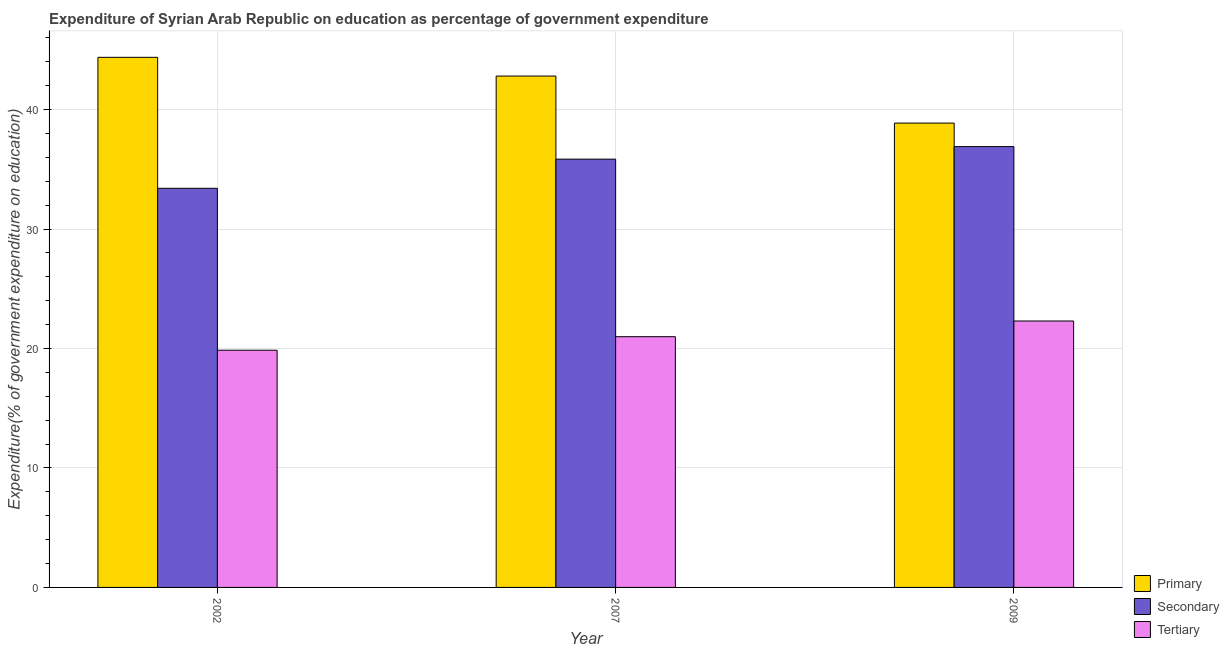How many different coloured bars are there?
Make the answer very short. 3. How many bars are there on the 3rd tick from the left?
Your answer should be very brief. 3. In how many cases, is the number of bars for a given year not equal to the number of legend labels?
Your response must be concise. 0. What is the expenditure on secondary education in 2009?
Provide a short and direct response. 36.9. Across all years, what is the maximum expenditure on primary education?
Provide a short and direct response. 44.38. Across all years, what is the minimum expenditure on tertiary education?
Provide a short and direct response. 19.86. In which year was the expenditure on secondary education maximum?
Offer a terse response. 2009. What is the total expenditure on primary education in the graph?
Your answer should be very brief. 126.06. What is the difference between the expenditure on secondary education in 2007 and that in 2009?
Keep it short and to the point. -1.05. What is the difference between the expenditure on secondary education in 2007 and the expenditure on primary education in 2002?
Offer a terse response. 2.44. What is the average expenditure on secondary education per year?
Make the answer very short. 35.39. In the year 2007, what is the difference between the expenditure on primary education and expenditure on secondary education?
Your answer should be very brief. 0. What is the ratio of the expenditure on tertiary education in 2002 to that in 2009?
Give a very brief answer. 0.89. What is the difference between the highest and the second highest expenditure on tertiary education?
Provide a short and direct response. 1.31. What is the difference between the highest and the lowest expenditure on secondary education?
Provide a short and direct response. 3.49. Is the sum of the expenditure on tertiary education in 2007 and 2009 greater than the maximum expenditure on primary education across all years?
Your response must be concise. Yes. What does the 3rd bar from the left in 2002 represents?
Your answer should be compact. Tertiary. What does the 2nd bar from the right in 2007 represents?
Keep it short and to the point. Secondary. Is it the case that in every year, the sum of the expenditure on primary education and expenditure on secondary education is greater than the expenditure on tertiary education?
Provide a short and direct response. Yes. Are all the bars in the graph horizontal?
Offer a very short reply. No. Are the values on the major ticks of Y-axis written in scientific E-notation?
Keep it short and to the point. No. What is the title of the graph?
Offer a very short reply. Expenditure of Syrian Arab Republic on education as percentage of government expenditure. What is the label or title of the X-axis?
Your response must be concise. Year. What is the label or title of the Y-axis?
Offer a very short reply. Expenditure(% of government expenditure on education). What is the Expenditure(% of government expenditure on education) of Primary in 2002?
Keep it short and to the point. 44.38. What is the Expenditure(% of government expenditure on education) of Secondary in 2002?
Give a very brief answer. 33.41. What is the Expenditure(% of government expenditure on education) in Tertiary in 2002?
Offer a very short reply. 19.86. What is the Expenditure(% of government expenditure on education) of Primary in 2007?
Your answer should be very brief. 42.81. What is the Expenditure(% of government expenditure on education) of Secondary in 2007?
Offer a terse response. 35.85. What is the Expenditure(% of government expenditure on education) in Tertiary in 2007?
Your answer should be very brief. 20.99. What is the Expenditure(% of government expenditure on education) in Primary in 2009?
Make the answer very short. 38.87. What is the Expenditure(% of government expenditure on education) in Secondary in 2009?
Offer a terse response. 36.9. What is the Expenditure(% of government expenditure on education) of Tertiary in 2009?
Your answer should be very brief. 22.31. Across all years, what is the maximum Expenditure(% of government expenditure on education) in Primary?
Your answer should be very brief. 44.38. Across all years, what is the maximum Expenditure(% of government expenditure on education) in Secondary?
Provide a succinct answer. 36.9. Across all years, what is the maximum Expenditure(% of government expenditure on education) of Tertiary?
Your answer should be very brief. 22.31. Across all years, what is the minimum Expenditure(% of government expenditure on education) of Primary?
Make the answer very short. 38.87. Across all years, what is the minimum Expenditure(% of government expenditure on education) in Secondary?
Your answer should be very brief. 33.41. Across all years, what is the minimum Expenditure(% of government expenditure on education) of Tertiary?
Keep it short and to the point. 19.86. What is the total Expenditure(% of government expenditure on education) of Primary in the graph?
Give a very brief answer. 126.06. What is the total Expenditure(% of government expenditure on education) of Secondary in the graph?
Offer a terse response. 106.17. What is the total Expenditure(% of government expenditure on education) of Tertiary in the graph?
Offer a terse response. 63.15. What is the difference between the Expenditure(% of government expenditure on education) of Primary in 2002 and that in 2007?
Make the answer very short. 1.57. What is the difference between the Expenditure(% of government expenditure on education) in Secondary in 2002 and that in 2007?
Keep it short and to the point. -2.44. What is the difference between the Expenditure(% of government expenditure on education) of Tertiary in 2002 and that in 2007?
Offer a very short reply. -1.13. What is the difference between the Expenditure(% of government expenditure on education) in Primary in 2002 and that in 2009?
Make the answer very short. 5.51. What is the difference between the Expenditure(% of government expenditure on education) in Secondary in 2002 and that in 2009?
Your response must be concise. -3.49. What is the difference between the Expenditure(% of government expenditure on education) of Tertiary in 2002 and that in 2009?
Provide a succinct answer. -2.45. What is the difference between the Expenditure(% of government expenditure on education) in Primary in 2007 and that in 2009?
Offer a terse response. 3.94. What is the difference between the Expenditure(% of government expenditure on education) in Secondary in 2007 and that in 2009?
Your answer should be very brief. -1.05. What is the difference between the Expenditure(% of government expenditure on education) of Tertiary in 2007 and that in 2009?
Your response must be concise. -1.31. What is the difference between the Expenditure(% of government expenditure on education) of Primary in 2002 and the Expenditure(% of government expenditure on education) of Secondary in 2007?
Your answer should be compact. 8.52. What is the difference between the Expenditure(% of government expenditure on education) of Primary in 2002 and the Expenditure(% of government expenditure on education) of Tertiary in 2007?
Make the answer very short. 23.39. What is the difference between the Expenditure(% of government expenditure on education) of Secondary in 2002 and the Expenditure(% of government expenditure on education) of Tertiary in 2007?
Provide a short and direct response. 12.42. What is the difference between the Expenditure(% of government expenditure on education) of Primary in 2002 and the Expenditure(% of government expenditure on education) of Secondary in 2009?
Provide a short and direct response. 7.47. What is the difference between the Expenditure(% of government expenditure on education) of Primary in 2002 and the Expenditure(% of government expenditure on education) of Tertiary in 2009?
Your response must be concise. 22.07. What is the difference between the Expenditure(% of government expenditure on education) in Secondary in 2002 and the Expenditure(% of government expenditure on education) in Tertiary in 2009?
Provide a short and direct response. 11.11. What is the difference between the Expenditure(% of government expenditure on education) of Primary in 2007 and the Expenditure(% of government expenditure on education) of Secondary in 2009?
Give a very brief answer. 5.91. What is the difference between the Expenditure(% of government expenditure on education) in Primary in 2007 and the Expenditure(% of government expenditure on education) in Tertiary in 2009?
Offer a very short reply. 20.5. What is the difference between the Expenditure(% of government expenditure on education) in Secondary in 2007 and the Expenditure(% of government expenditure on education) in Tertiary in 2009?
Ensure brevity in your answer.  13.55. What is the average Expenditure(% of government expenditure on education) in Primary per year?
Give a very brief answer. 42.02. What is the average Expenditure(% of government expenditure on education) of Secondary per year?
Provide a short and direct response. 35.39. What is the average Expenditure(% of government expenditure on education) of Tertiary per year?
Give a very brief answer. 21.05. In the year 2002, what is the difference between the Expenditure(% of government expenditure on education) of Primary and Expenditure(% of government expenditure on education) of Secondary?
Ensure brevity in your answer.  10.96. In the year 2002, what is the difference between the Expenditure(% of government expenditure on education) in Primary and Expenditure(% of government expenditure on education) in Tertiary?
Give a very brief answer. 24.52. In the year 2002, what is the difference between the Expenditure(% of government expenditure on education) of Secondary and Expenditure(% of government expenditure on education) of Tertiary?
Offer a terse response. 13.56. In the year 2007, what is the difference between the Expenditure(% of government expenditure on education) of Primary and Expenditure(% of government expenditure on education) of Secondary?
Provide a short and direct response. 6.96. In the year 2007, what is the difference between the Expenditure(% of government expenditure on education) in Primary and Expenditure(% of government expenditure on education) in Tertiary?
Provide a succinct answer. 21.82. In the year 2007, what is the difference between the Expenditure(% of government expenditure on education) in Secondary and Expenditure(% of government expenditure on education) in Tertiary?
Your answer should be compact. 14.86. In the year 2009, what is the difference between the Expenditure(% of government expenditure on education) of Primary and Expenditure(% of government expenditure on education) of Secondary?
Provide a short and direct response. 1.97. In the year 2009, what is the difference between the Expenditure(% of government expenditure on education) of Primary and Expenditure(% of government expenditure on education) of Tertiary?
Your answer should be very brief. 16.57. In the year 2009, what is the difference between the Expenditure(% of government expenditure on education) in Secondary and Expenditure(% of government expenditure on education) in Tertiary?
Your answer should be very brief. 14.6. What is the ratio of the Expenditure(% of government expenditure on education) of Primary in 2002 to that in 2007?
Make the answer very short. 1.04. What is the ratio of the Expenditure(% of government expenditure on education) in Secondary in 2002 to that in 2007?
Your answer should be compact. 0.93. What is the ratio of the Expenditure(% of government expenditure on education) in Tertiary in 2002 to that in 2007?
Ensure brevity in your answer.  0.95. What is the ratio of the Expenditure(% of government expenditure on education) in Primary in 2002 to that in 2009?
Your response must be concise. 1.14. What is the ratio of the Expenditure(% of government expenditure on education) of Secondary in 2002 to that in 2009?
Your answer should be very brief. 0.91. What is the ratio of the Expenditure(% of government expenditure on education) in Tertiary in 2002 to that in 2009?
Your answer should be very brief. 0.89. What is the ratio of the Expenditure(% of government expenditure on education) in Primary in 2007 to that in 2009?
Your answer should be very brief. 1.1. What is the ratio of the Expenditure(% of government expenditure on education) of Secondary in 2007 to that in 2009?
Make the answer very short. 0.97. What is the ratio of the Expenditure(% of government expenditure on education) in Tertiary in 2007 to that in 2009?
Make the answer very short. 0.94. What is the difference between the highest and the second highest Expenditure(% of government expenditure on education) of Primary?
Make the answer very short. 1.57. What is the difference between the highest and the second highest Expenditure(% of government expenditure on education) of Secondary?
Make the answer very short. 1.05. What is the difference between the highest and the second highest Expenditure(% of government expenditure on education) in Tertiary?
Keep it short and to the point. 1.31. What is the difference between the highest and the lowest Expenditure(% of government expenditure on education) of Primary?
Provide a short and direct response. 5.51. What is the difference between the highest and the lowest Expenditure(% of government expenditure on education) of Secondary?
Your answer should be compact. 3.49. What is the difference between the highest and the lowest Expenditure(% of government expenditure on education) of Tertiary?
Offer a very short reply. 2.45. 